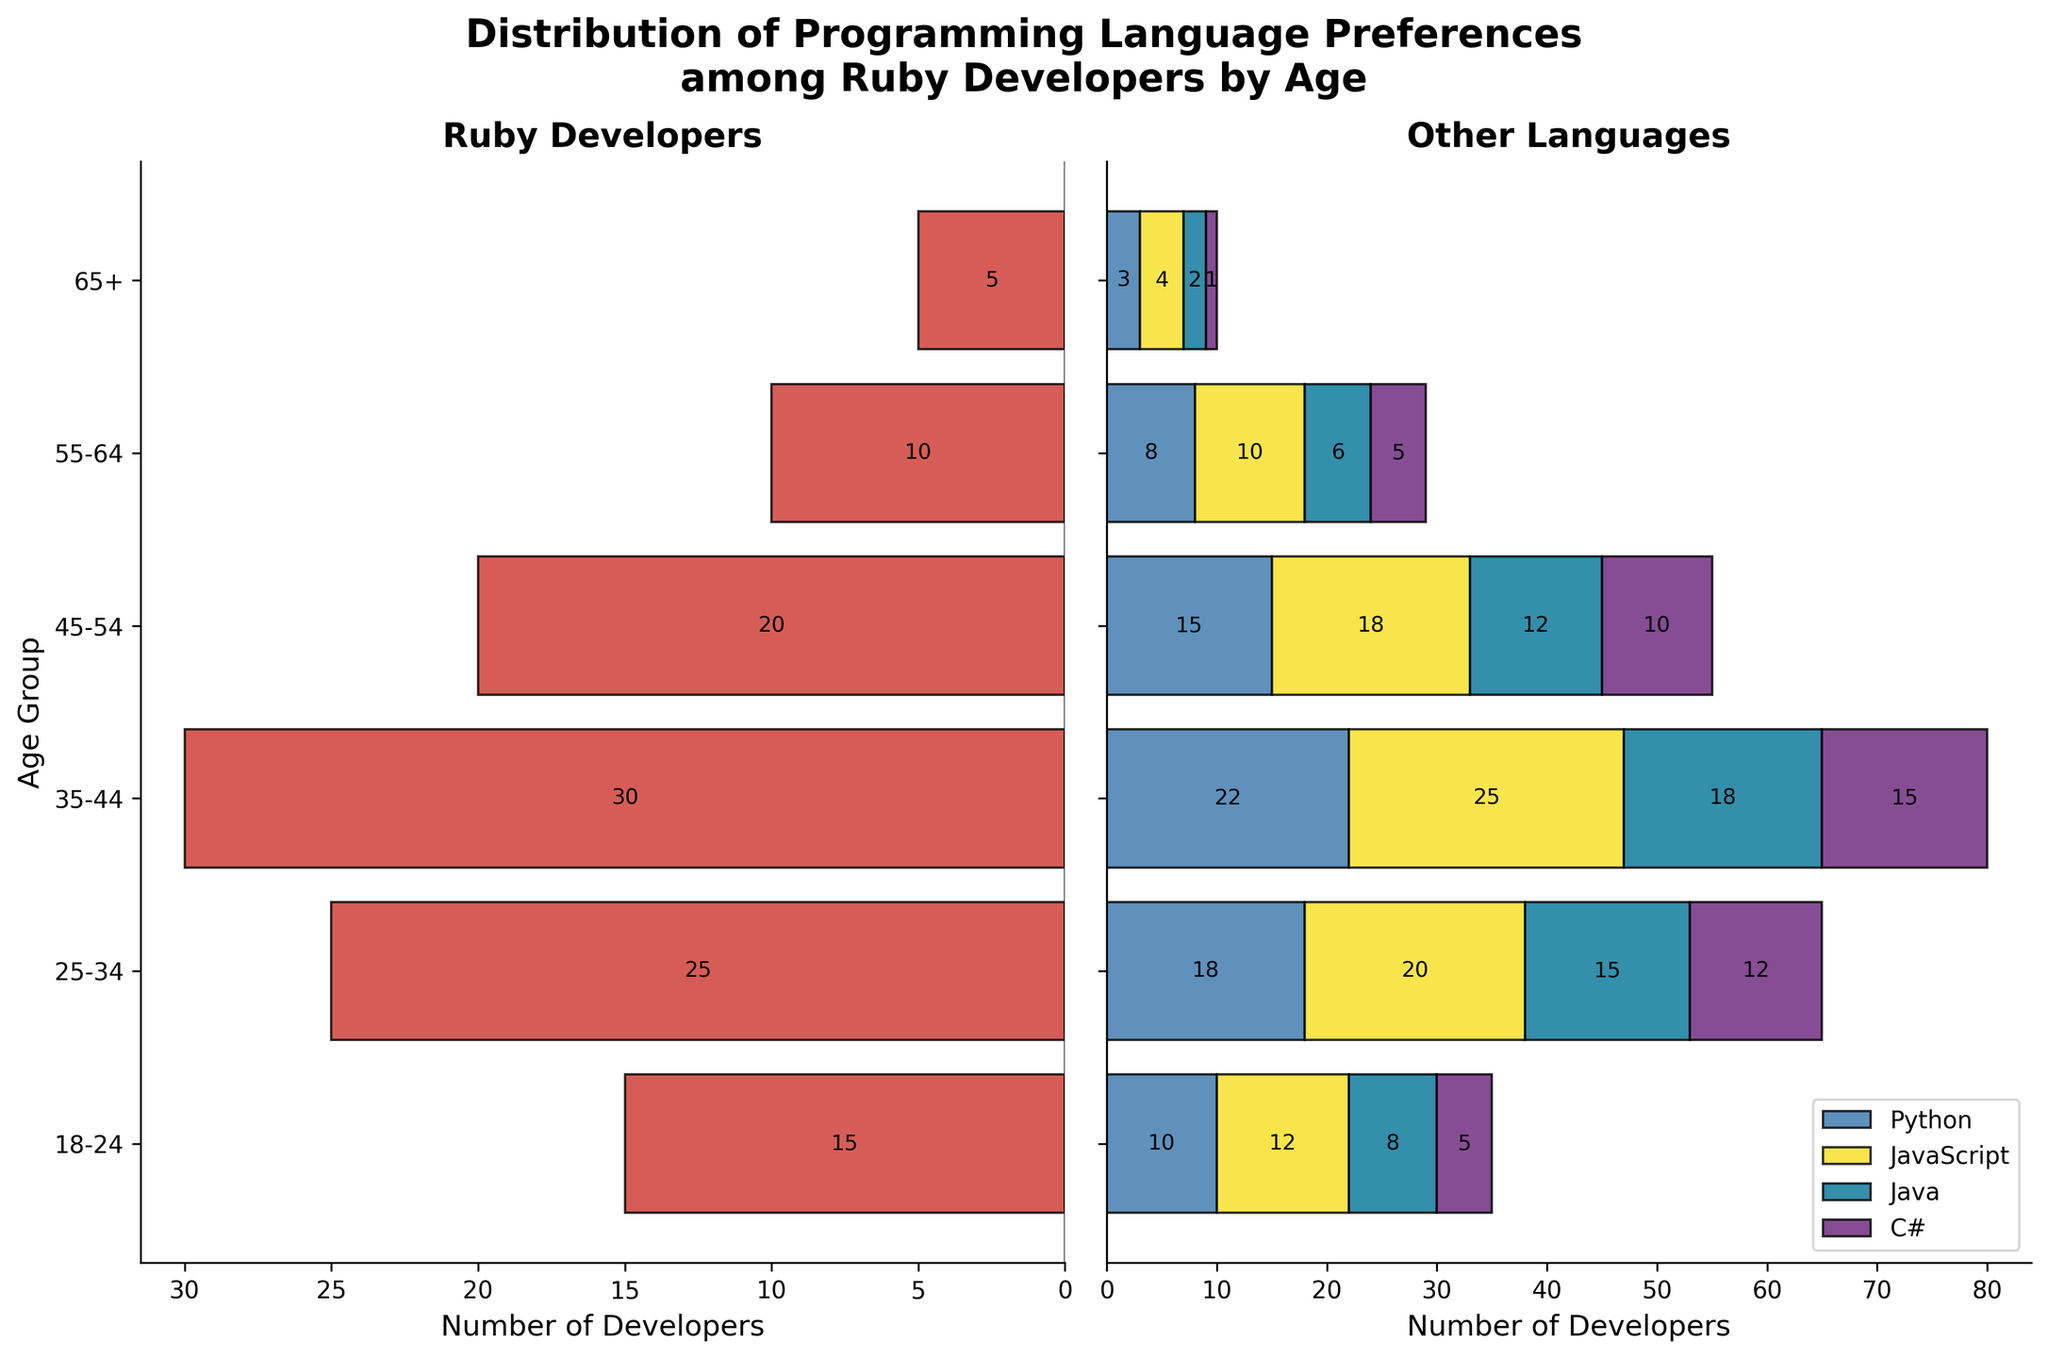What is the title of the plot? The title of the plot is found at the top of the figure and is formatted in bold text.
Answer: Distribution of Programming Language Preferences among Ruby Developers by Age Which age group has the highest number of Ruby developers? The highest bar in the Ruby Developers section (the left side of the figure) indicates the age group with the most Ruby developers.
Answer: 35-44 How many developers aged 25-34 prefer Python? The length of the Python (blue) bar for the age group 25-34 on the right side of the figure shows the number of developers.
Answer: 18 Compare the number of Ruby developers aged 45-54 to those aged 55-64. The length of the Ruby bars for age groups 45-54 and 55-64 on the left side of the plot can be compared.
Answer: 45-54 has more Ruby developers than 55-64 What is the total number of developers in the 18-24 age group for all languages? Sum the lengths of all the bars for the age group 18-24 on both sides of the plot.
Answer: 15 + 10 + 12 + 8 + 5 = 50 Which programming language has the least number of developers aged 65+? The shortest bar for the age group 65+ on the right side indicates the programming language with the fewest developers.
Answer: C# How does the preference for JavaScript compare for the age groups 18-24 and 35-44? Compare the lengths of the JavaScript (yellow) bars for the age groups 18-24 and 35-44.
Answer: 35-44 has more developers than 18-24 What is the number of C# developers aged 45-54 compared to those aged 18-24 and 25-34 combined? Sum the lengths of the C# bars for ages 18-24 and 25-34, then compare with the length of the C# bar for age 45-54.
Answer: 5 + 12 = 17, which is more than 10 How do the preferences for Java and C# compare for the age group 55-64? Compare the lengths of the Java (green) and C# (purple) bars for the age group 55-64.
Answer: Java has more developers than C# Which other language has the closest number of developers aged 35-44 compared to Ruby developers of the same age group? Identify the bar from other languages (right side) that is closest to the Ruby developers bar (left side) for the age group 35-44.
Answer: JavaScript 